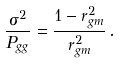<formula> <loc_0><loc_0><loc_500><loc_500>\frac { \sigma ^ { 2 } } { P _ { g g } } = \frac { 1 - r _ { g m } ^ { 2 } } { r _ { g m } ^ { 2 } } \, .</formula> 